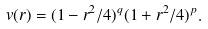<formula> <loc_0><loc_0><loc_500><loc_500>v ( r ) = ( 1 - r ^ { 2 } / 4 ) ^ { q } ( 1 + r ^ { 2 } / 4 ) ^ { p } .</formula> 